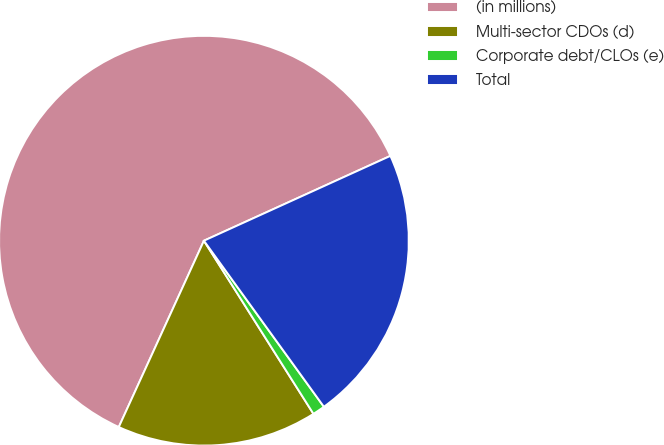Convert chart. <chart><loc_0><loc_0><loc_500><loc_500><pie_chart><fcel>(in millions)<fcel>Multi-sector CDOs (d)<fcel>Corporate debt/CLOs (e)<fcel>Total<nl><fcel>61.39%<fcel>15.8%<fcel>0.98%<fcel>21.84%<nl></chart> 